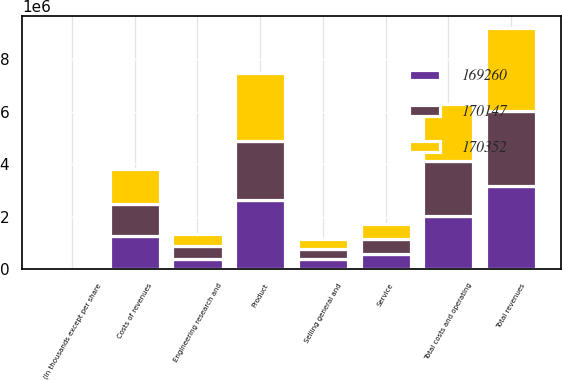Convert chart. <chart><loc_0><loc_0><loc_500><loc_500><stacked_bar_chart><ecel><fcel>(In thousands except per share<fcel>Product<fcel>Service<fcel>Total revenues<fcel>Costs of revenues<fcel>Engineering research and<fcel>Selling general and<fcel>Total costs and operating<nl><fcel>170147<fcel>2013<fcel>2.24715e+06<fcel>595634<fcel>2.84278e+06<fcel>1.23745e+06<fcel>487832<fcel>387812<fcel>2.1131e+06<nl><fcel>170352<fcel>2012<fcel>2.59776e+06<fcel>574189<fcel>3.17194e+06<fcel>1.33002e+06<fcel>452937<fcel>372666<fcel>2.15562e+06<nl><fcel>169260<fcel>2011<fcel>2.61344e+06<fcel>561729<fcel>3.17517e+06<fcel>1.25924e+06<fcel>386163<fcel>369431<fcel>2.01484e+06<nl></chart> 